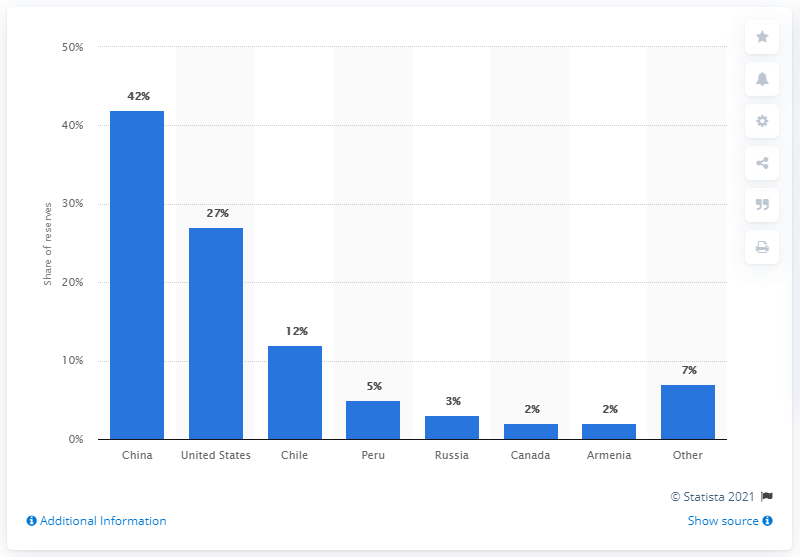Give some essential details in this illustration. In 2016, China had the largest reserves of molybdenum, a metal with important industrial applications. 